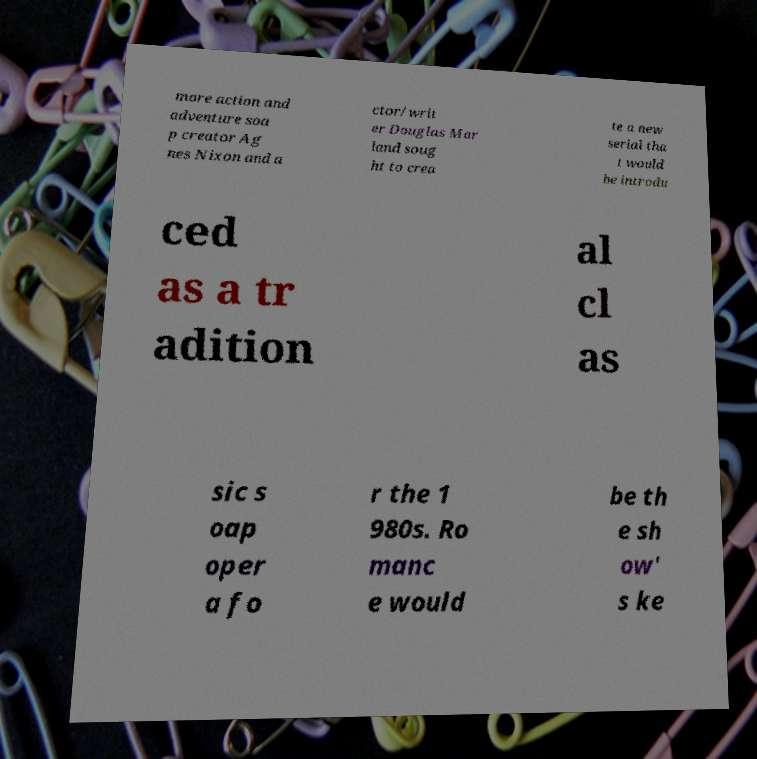Please read and relay the text visible in this image. What does it say? more action and adventure soa p creator Ag nes Nixon and a ctor/writ er Douglas Mar land soug ht to crea te a new serial tha t would be introdu ced as a tr adition al cl as sic s oap oper a fo r the 1 980s. Ro manc e would be th e sh ow' s ke 